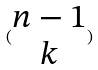Convert formula to latex. <formula><loc_0><loc_0><loc_500><loc_500>( \begin{matrix} n - 1 \\ k \end{matrix} )</formula> 